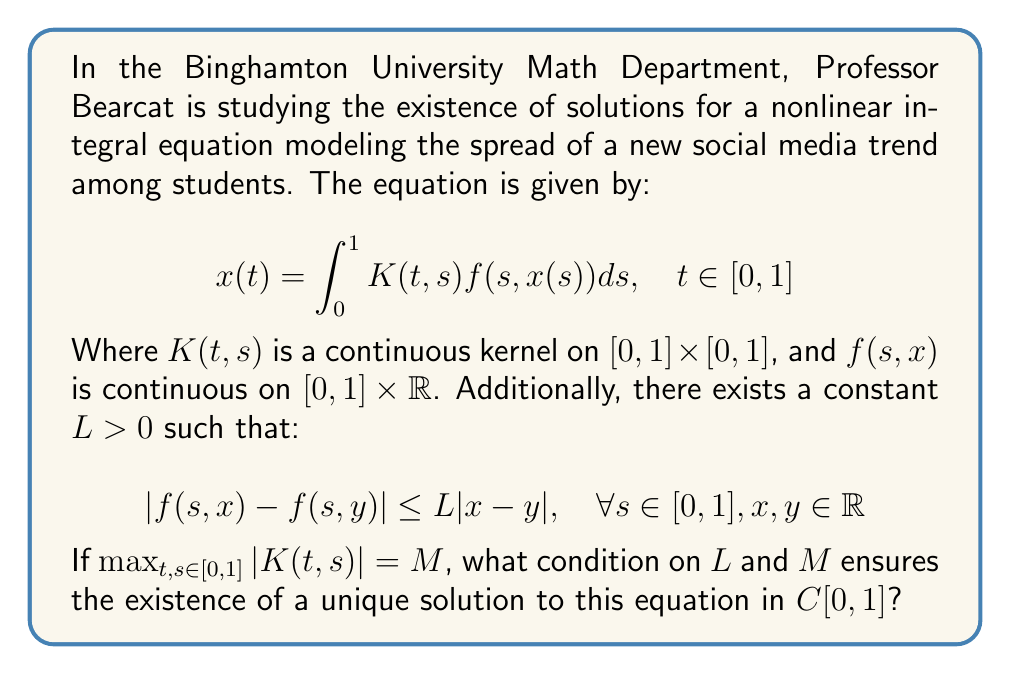Show me your answer to this math problem. To solve this problem, we'll use the Banach Fixed Point Theorem (also known as the Contraction Mapping Principle) in the space $C[0,1]$ of continuous functions on $[0,1]$ with the supremum norm.

Step 1: Define the operator $T: C[0,1] \to C[0,1]$ by
$$(Tx)(t) = \int_0^1 K(t,s)f(s,x(s))ds$$

Step 2: Show that $T$ is a contraction mapping if $LM < 1$. For any $x, y \in C[0,1]$:

$$\begin{align*}
|(Tx)(t) - (Ty)(t)| &= \left|\int_0^1 K(t,s)[f(s,x(s)) - f(s,y(s))]ds\right| \\
&\leq \int_0^1 |K(t,s)| \cdot |f(s,x(s)) - f(s,y(s))|ds \\
&\leq \int_0^1 M \cdot L|x(s) - y(s)|ds \\
&\leq ML \int_0^1 \|x - y\|_{\infty}ds \\
&= ML\|x - y\|_{\infty}
\end{align*}$$

Step 3: Taking the supremum over $t \in [0,1]$, we get:
$$\|Tx - Ty\|_{\infty} \leq ML\|x - y\|_{\infty}$$

Step 4: For $T$ to be a contraction, we need $ML < 1$.

Step 5: If $ML < 1$, then by the Banach Fixed Point Theorem, $T$ has a unique fixed point in $C[0,1]$, which is the unique solution to our integral equation.
Answer: $ML < 1$ 